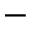Convert formula to latex. <formula><loc_0><loc_0><loc_500><loc_500>^ { - }</formula> 